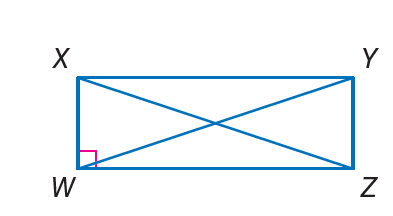Answer the mathemtical geometry problem and directly provide the correct option letter.
Question: Quadrilateral W X Y Z is a rectangle. If X Z = 2 c and Z Y = 6, and X Y = 8, find W Y.
Choices: A: 6 B: 8 C: 10 D: 20 C 